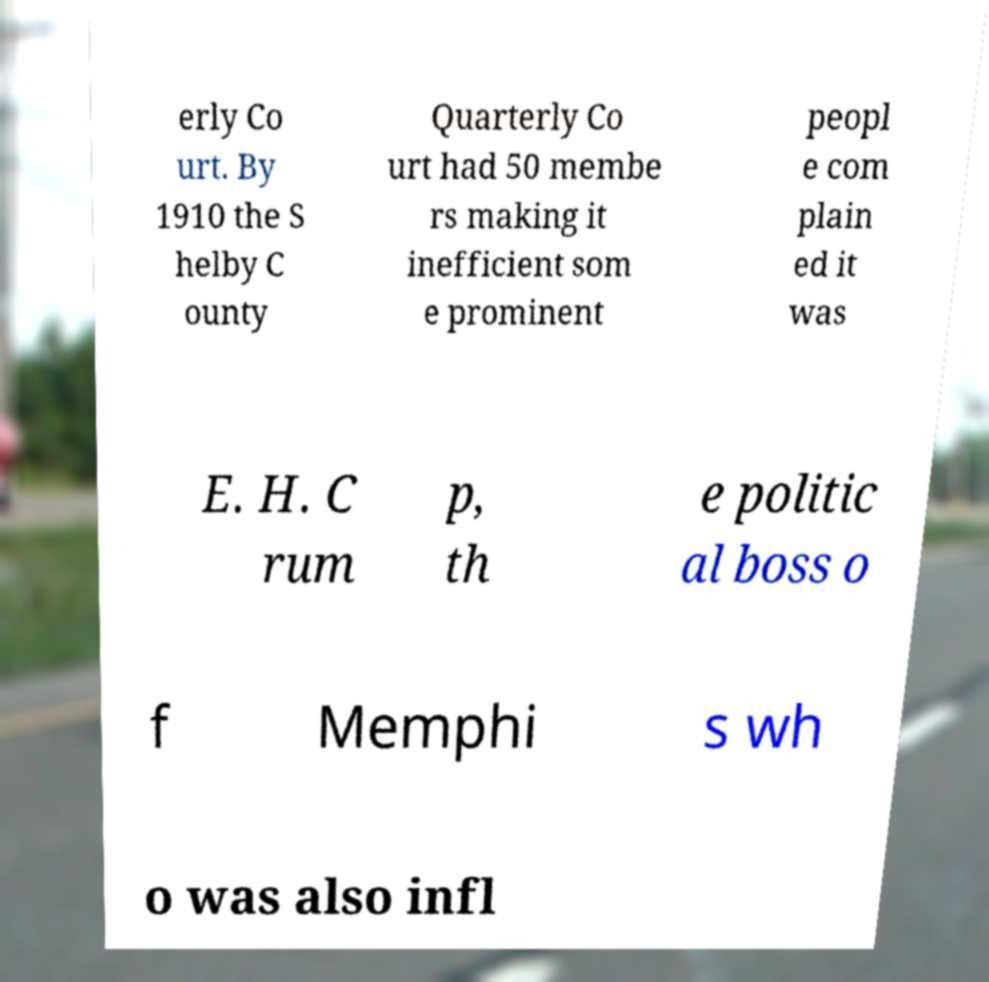There's text embedded in this image that I need extracted. Can you transcribe it verbatim? erly Co urt. By 1910 the S helby C ounty Quarterly Co urt had 50 membe rs making it inefficient som e prominent peopl e com plain ed it was E. H. C rum p, th e politic al boss o f Memphi s wh o was also infl 